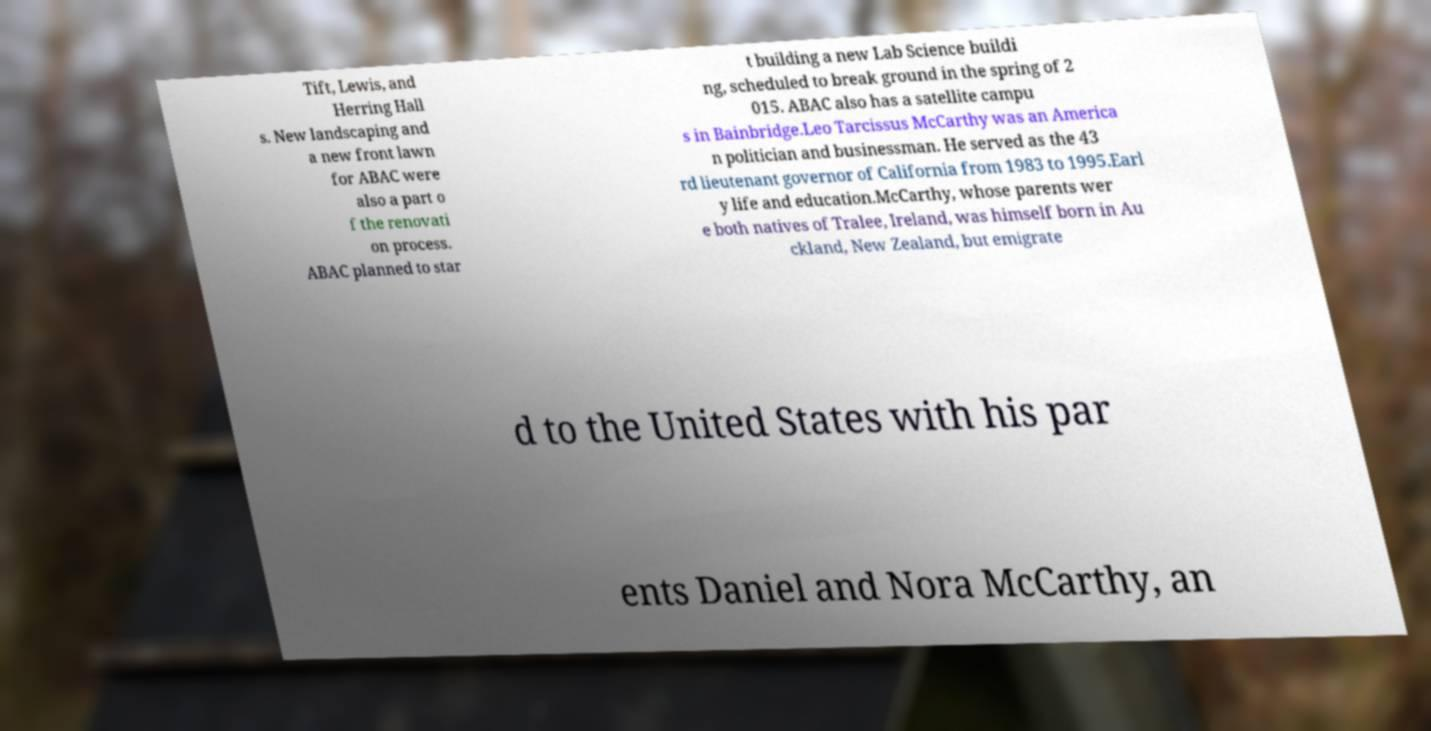Could you assist in decoding the text presented in this image and type it out clearly? Tift, Lewis, and Herring Hall s. New landscaping and a new front lawn for ABAC were also a part o f the renovati on process. ABAC planned to star t building a new Lab Science buildi ng, scheduled to break ground in the spring of 2 015. ABAC also has a satellite campu s in Bainbridge.Leo Tarcissus McCarthy was an America n politician and businessman. He served as the 43 rd lieutenant governor of California from 1983 to 1995.Earl y life and education.McCarthy, whose parents wer e both natives of Tralee, Ireland, was himself born in Au ckland, New Zealand, but emigrate d to the United States with his par ents Daniel and Nora McCarthy, an 